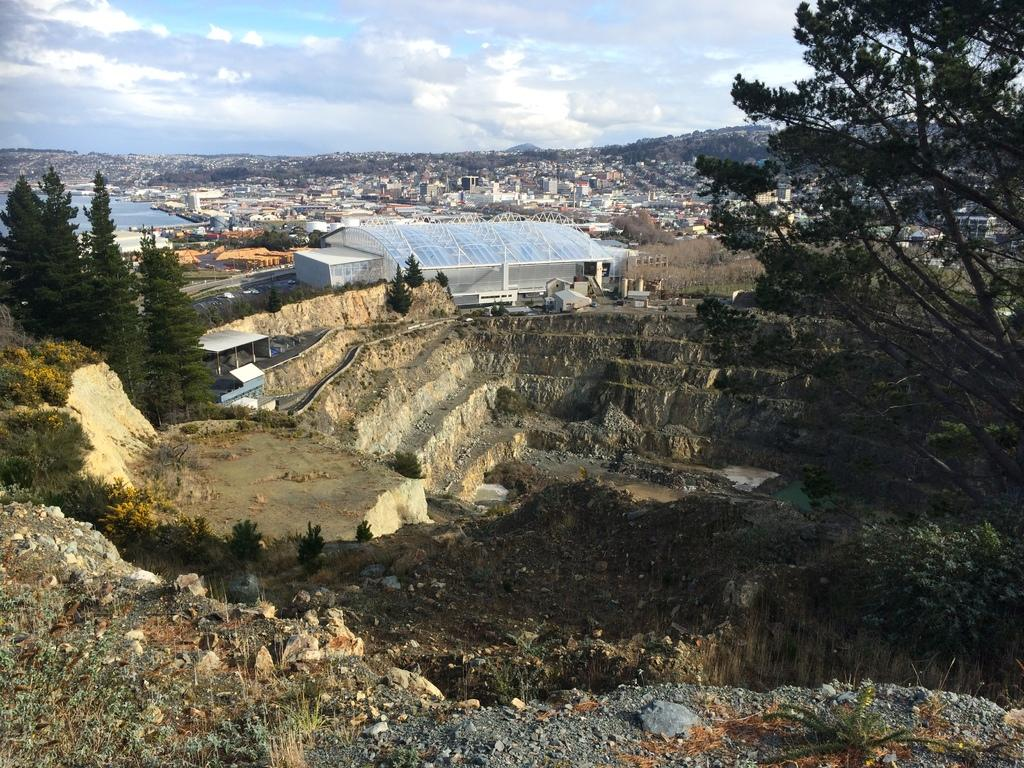What type of structures can be seen in the image? There are many buildings in the image. What natural elements are present in the image? There are trees, water, plants, mountains, and stones visible in the image. What architectural feature can be seen in the image? There is a wall in the image. What is visible in the background of the image? The sky is visible in the background of the image, with clouds present. What tax rate is applied to the chess pieces in the image? There are no chess pieces present in the image, and therefore no tax rate can be applied. What type of joke is being told by the mountains in the image? There are no jokes being told in the image; the mountains are a natural feature. 